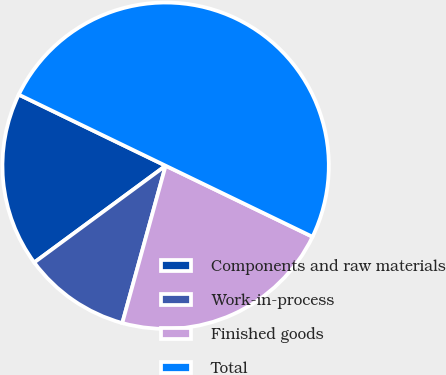<chart> <loc_0><loc_0><loc_500><loc_500><pie_chart><fcel>Components and raw materials<fcel>Work-in-process<fcel>Finished goods<fcel>Total<nl><fcel>17.28%<fcel>10.62%<fcel>22.11%<fcel>50.0%<nl></chart> 